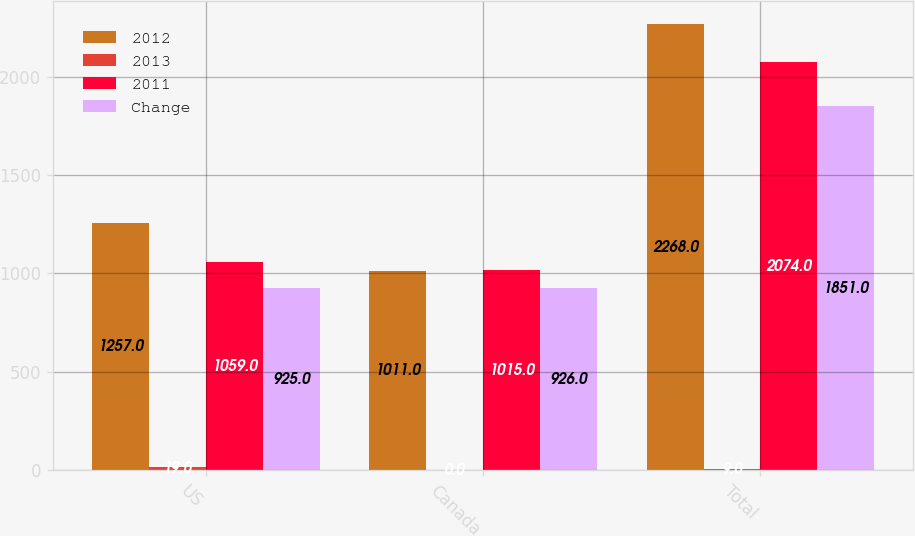<chart> <loc_0><loc_0><loc_500><loc_500><stacked_bar_chart><ecel><fcel>US<fcel>Canada<fcel>Total<nl><fcel>2012<fcel>1257<fcel>1011<fcel>2268<nl><fcel>2013<fcel>19<fcel>0<fcel>9<nl><fcel>2011<fcel>1059<fcel>1015<fcel>2074<nl><fcel>Change<fcel>925<fcel>926<fcel>1851<nl></chart> 